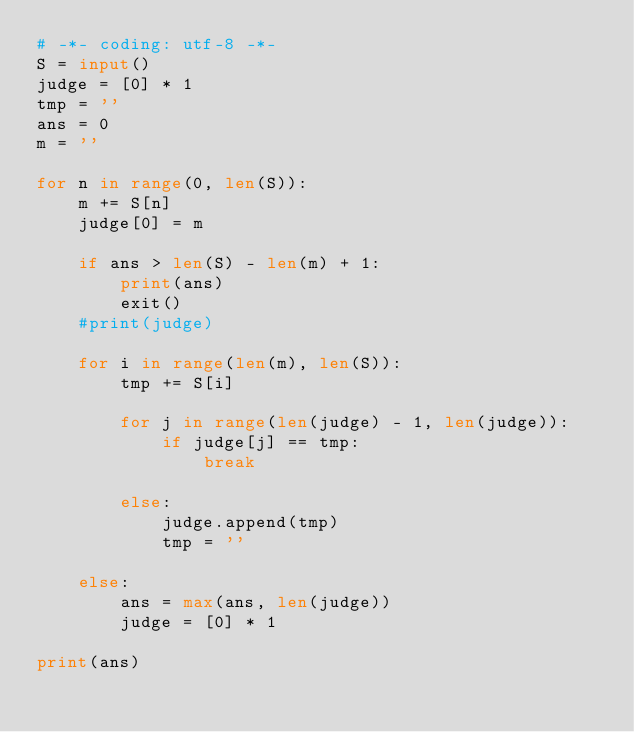<code> <loc_0><loc_0><loc_500><loc_500><_Python_># -*- coding: utf-8 -*-
S = input()
judge = [0] * 1
tmp = ''
ans = 0
m = ''

for n in range(0, len(S)):
	m += S[n]
	judge[0] = m

	if ans > len(S) - len(m) + 1:
		print(ans)
		exit()
	#print(judge)

	for i in range(len(m), len(S)):
		tmp += S[i]
		
		for j in range(len(judge) - 1, len(judge)):
			if judge[j] == tmp:
				break

		else:
			judge.append(tmp)
			tmp = ''
	
	else:
		ans = max(ans, len(judge))
		judge = [0] * 1

print(ans)</code> 